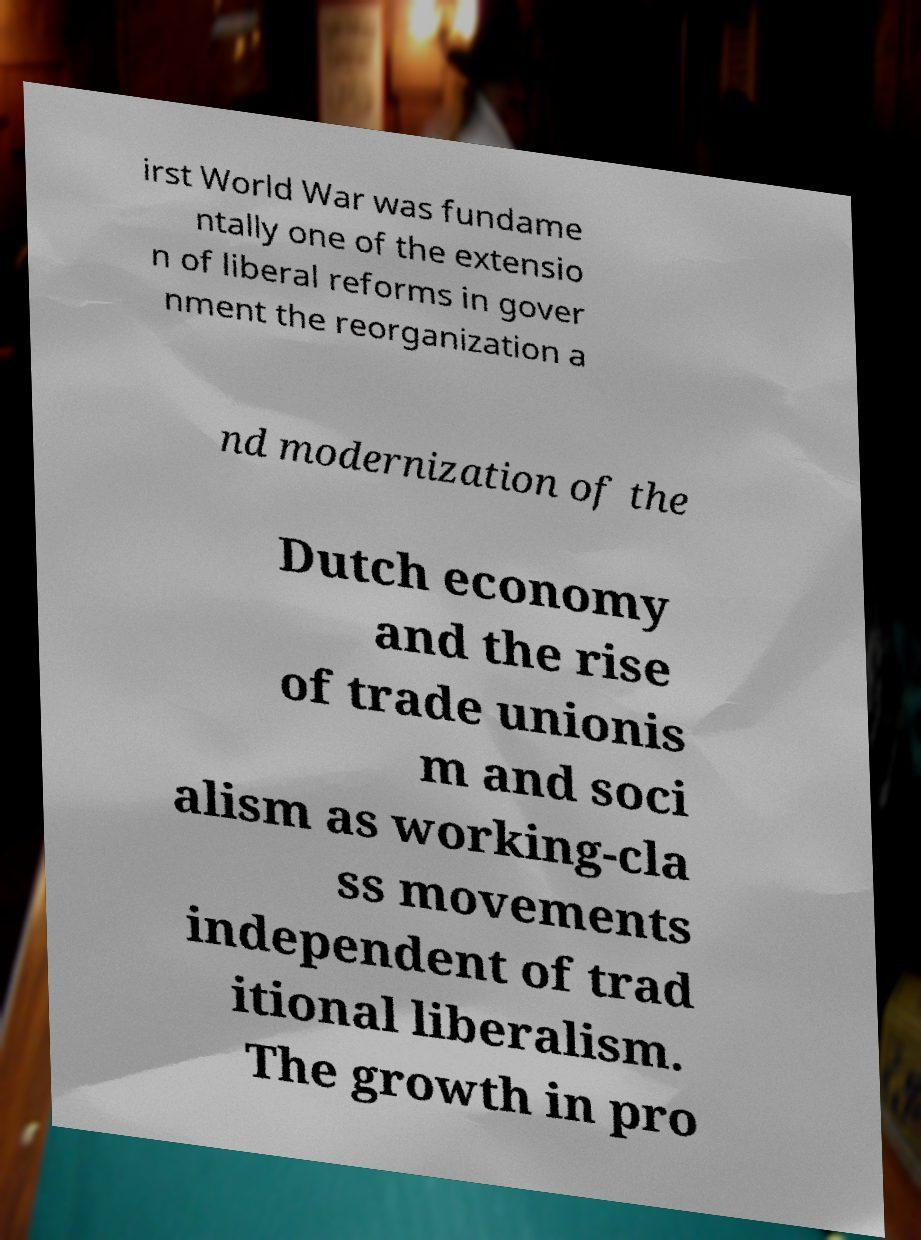Please identify and transcribe the text found in this image. irst World War was fundame ntally one of the extensio n of liberal reforms in gover nment the reorganization a nd modernization of the Dutch economy and the rise of trade unionis m and soci alism as working-cla ss movements independent of trad itional liberalism. The growth in pro 